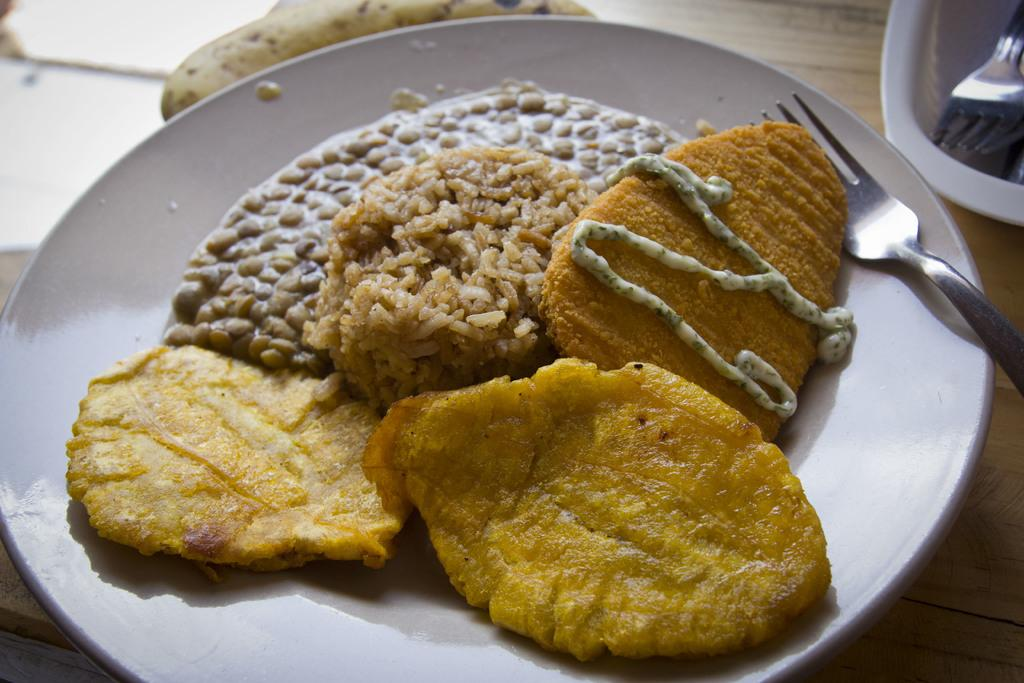What is on the plate that is visible in the image? The plate contains a food item. What utensil is placed on the plate? There is a fork on the plate. Are there any other plates in the image? Yes, there is another plate in the image. What is on the second plate? The second plate contains a fork. Where are the plates located in the image? Both plates are kept on a table. How many farmers are present in the image? There is no farmer present in the image. What are the boys doing in the image? There are no boys present in the image. 